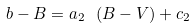Convert formula to latex. <formula><loc_0><loc_0><loc_500><loc_500>b - B = a _ { 2 } \ ( B - V ) + c _ { 2 }</formula> 